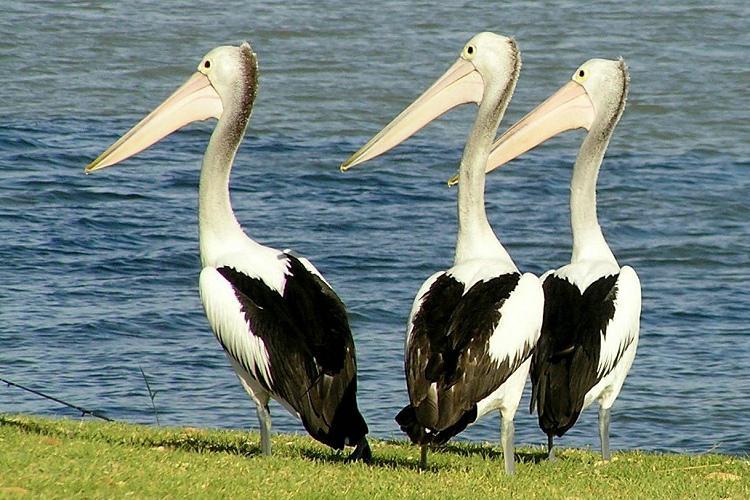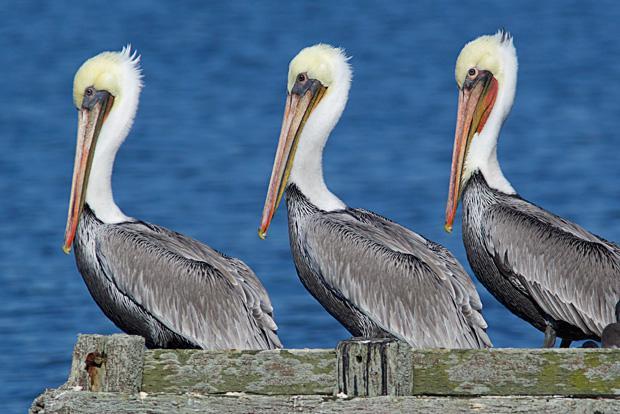The first image is the image on the left, the second image is the image on the right. Given the left and right images, does the statement "An image contains a trio of similarly posed left-facing pelicans with white heads and grey bodies." hold true? Answer yes or no. Yes. The first image is the image on the left, the second image is the image on the right. Assess this claim about the two images: "The right image contains exactly three birds all looking towards the left.". Correct or not? Answer yes or no. Yes. 